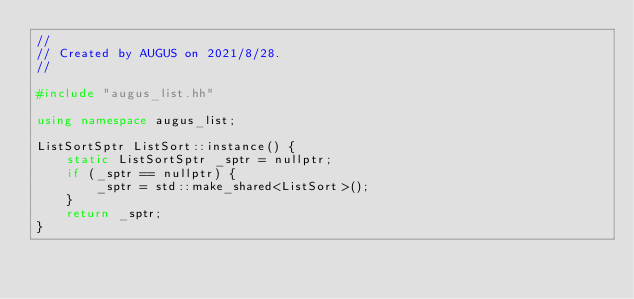Convert code to text. <code><loc_0><loc_0><loc_500><loc_500><_C++_>//
// Created by AUGUS on 2021/8/28.
//

#include "augus_list.hh"

using namespace augus_list;

ListSortSptr ListSort::instance() {
    static ListSortSptr _sptr = nullptr;
    if (_sptr == nullptr) {
        _sptr = std::make_shared<ListSort>();
    }
    return _sptr;
}
</code> 